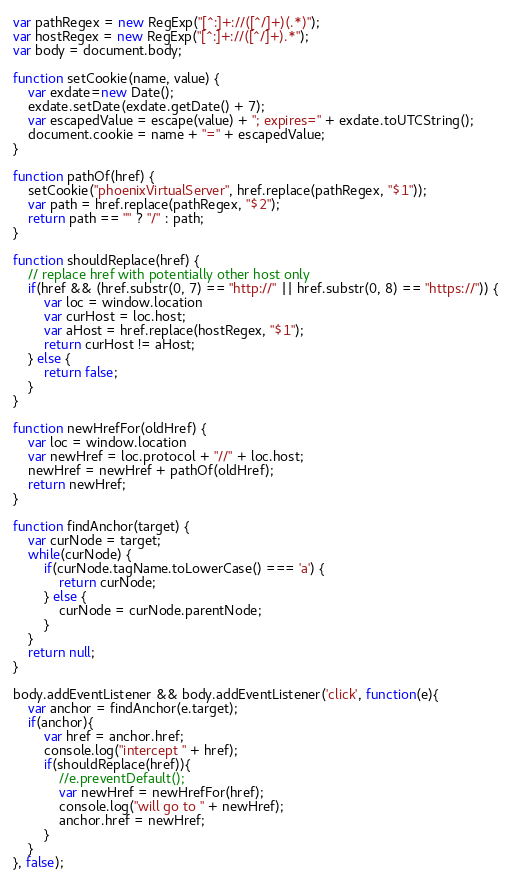<code> <loc_0><loc_0><loc_500><loc_500><_JavaScript_>var pathRegex = new RegExp("[^:]+://([^/]+)(.*)");
var hostRegex = new RegExp("[^:]+://([^/]+).*");
var body = document.body; 

function setCookie(name, value) {
	var exdate=new Date();
	exdate.setDate(exdate.getDate() + 7);
	var escapedValue = escape(value) + "; expires=" + exdate.toUTCString();
	document.cookie = name + "=" + escapedValue;
}

function pathOf(href) {
	setCookie("phoenixVirtualServer", href.replace(pathRegex, "$1"));
	var path = href.replace(pathRegex, "$2");
	return path == "" ? "/" : path;
}

function shouldReplace(href) {
	// replace href with potentially other host only
	if(href && (href.substr(0, 7) == "http://" || href.substr(0, 8) == "https://")) {
		var loc = window.location
		var curHost = loc.host;
		var aHost = href.replace(hostRegex, "$1");
		return curHost != aHost;
	} else {
		return false;
	}
}

function newHrefFor(oldHref) {
	var loc = window.location
	var newHref = loc.protocol + "//" + loc.host;
	newHref = newHref + pathOf(oldHref);
	return newHref;
}

function findAnchor(target) {
	var curNode = target;
	while(curNode) {
		if(curNode.tagName.toLowerCase() === 'a') {
			return curNode;
		} else {
			curNode = curNode.parentNode;
		}
	}
	return null;
}

body.addEventListener && body.addEventListener('click', function(e){
	var anchor = findAnchor(e.target);
    if(anchor){
        var href = anchor.href;
       	console.log("intercept " + href);
        if(shouldReplace(href)){
    		//e.preventDefault();
    		var newHref = newHrefFor(href);
        	console.log("will go to " + newHref);
        	anchor.href = newHref;
        }
    }
}, false);
</code> 